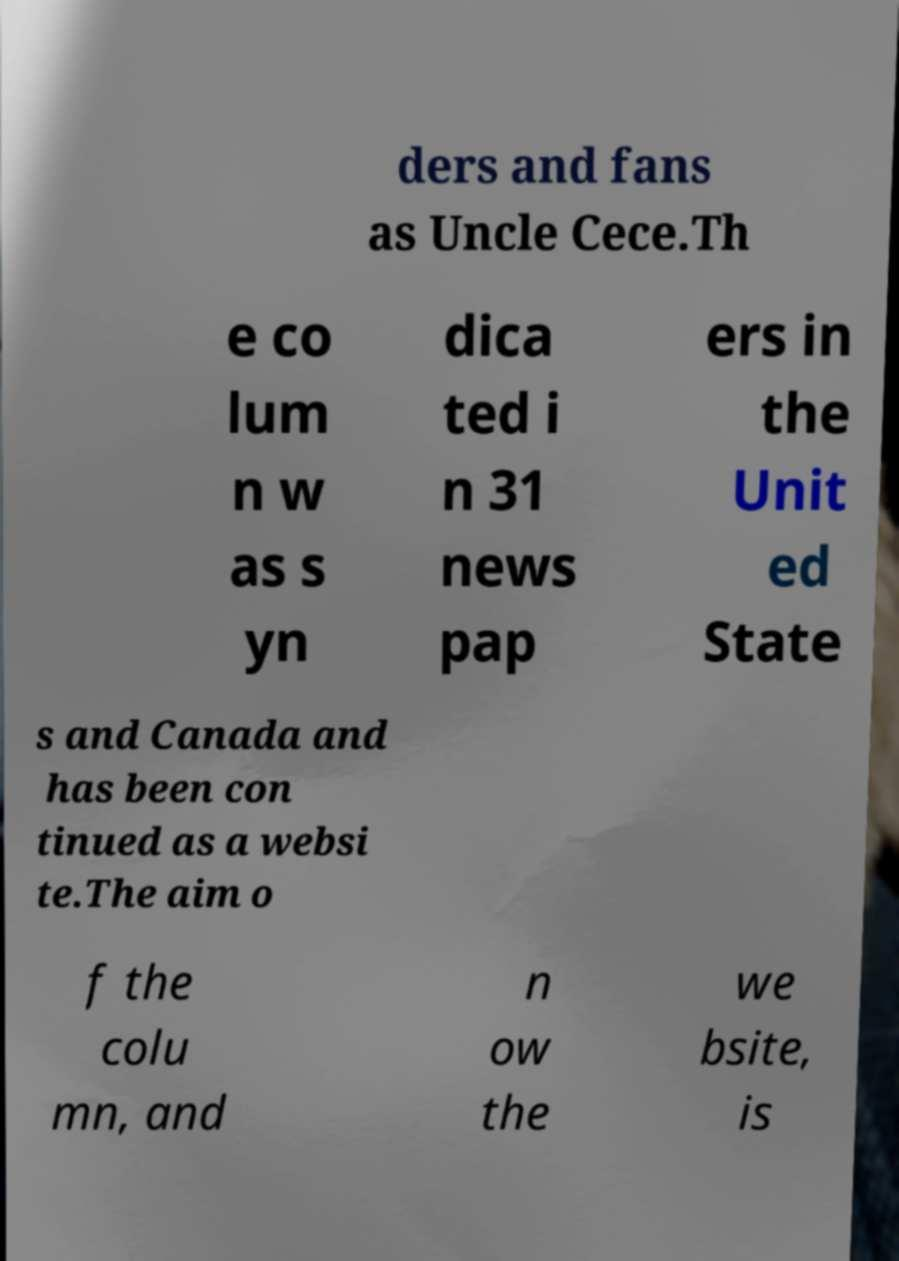Please read and relay the text visible in this image. What does it say? ders and fans as Uncle Cece.Th e co lum n w as s yn dica ted i n 31 news pap ers in the Unit ed State s and Canada and has been con tinued as a websi te.The aim o f the colu mn, and n ow the we bsite, is 